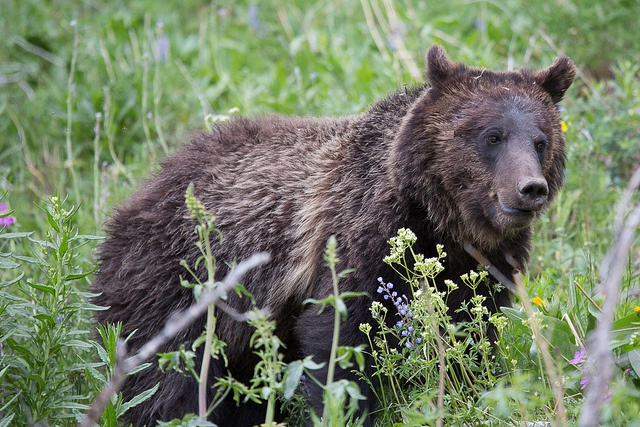Describe the objects in this image and their specific colors. I can see a bear in gray, black, and darkgray tones in this image. 